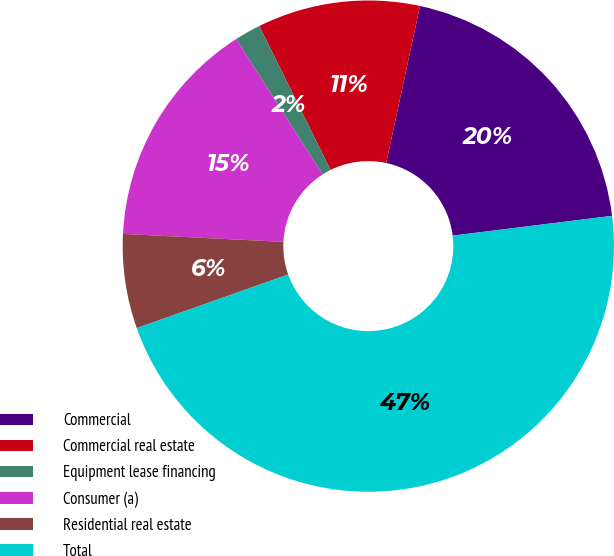<chart> <loc_0><loc_0><loc_500><loc_500><pie_chart><fcel>Commercial<fcel>Commercial real estate<fcel>Equipment lease financing<fcel>Consumer (a)<fcel>Residential real estate<fcel>Total<nl><fcel>19.66%<fcel>10.69%<fcel>1.72%<fcel>15.17%<fcel>6.21%<fcel>46.55%<nl></chart> 